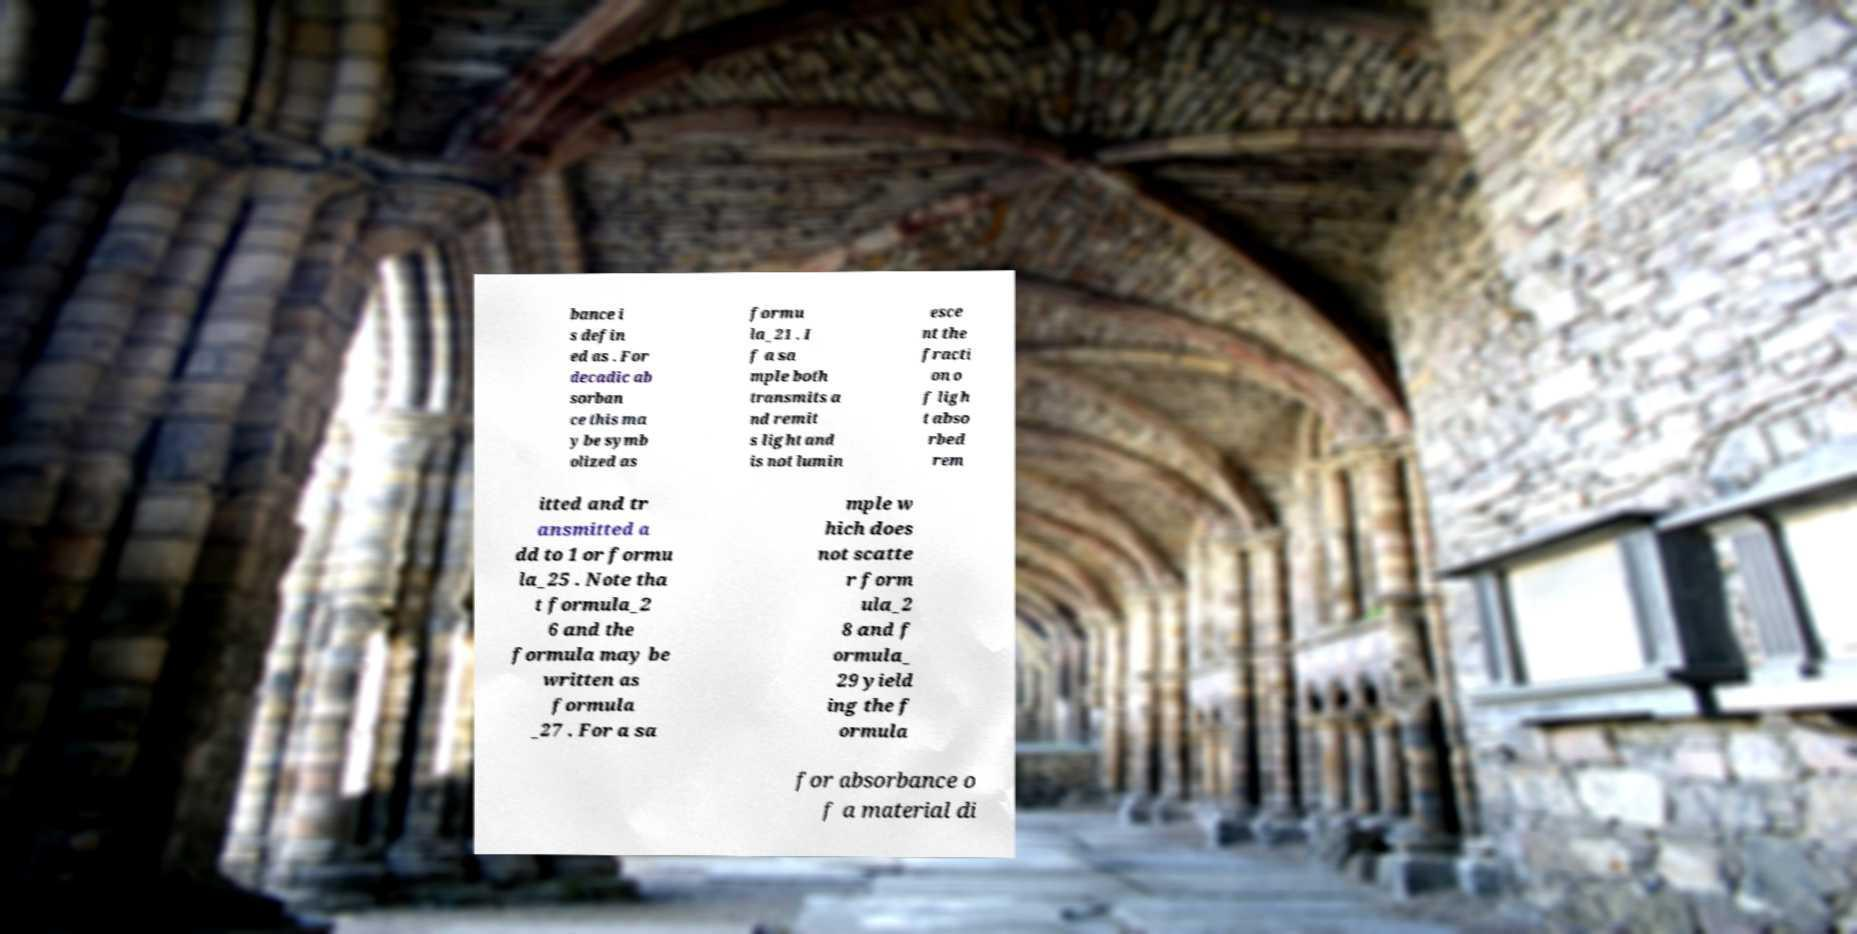Could you extract and type out the text from this image? bance i s defin ed as . For decadic ab sorban ce this ma y be symb olized as formu la_21 . I f a sa mple both transmits a nd remit s light and is not lumin esce nt the fracti on o f ligh t abso rbed rem itted and tr ansmitted a dd to 1 or formu la_25 . Note tha t formula_2 6 and the formula may be written as formula _27 . For a sa mple w hich does not scatte r form ula_2 8 and f ormula_ 29 yield ing the f ormula for absorbance o f a material di 